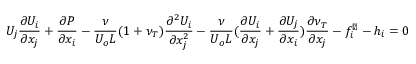<formula> <loc_0><loc_0><loc_500><loc_500>U _ { j } \frac { \partial U _ { i } } { \partial x _ { j } } + \frac { \partial P } { \partial x _ { i } } - \frac { \nu } { U _ { o } L } ( 1 + \nu _ { T } ) \frac { \partial ^ { 2 } U _ { i } } { \partial x _ { j } ^ { 2 } } - \frac { \nu } { U _ { o } L } ( \frac { \partial U _ { i } } { \partial x _ { j } } + \frac { \partial U _ { j } } { \partial x _ { i } } ) \frac { \partial \nu _ { T } } { \partial x _ { j } } - f _ { i } ^ { \perp } - h _ { i } = 0</formula> 